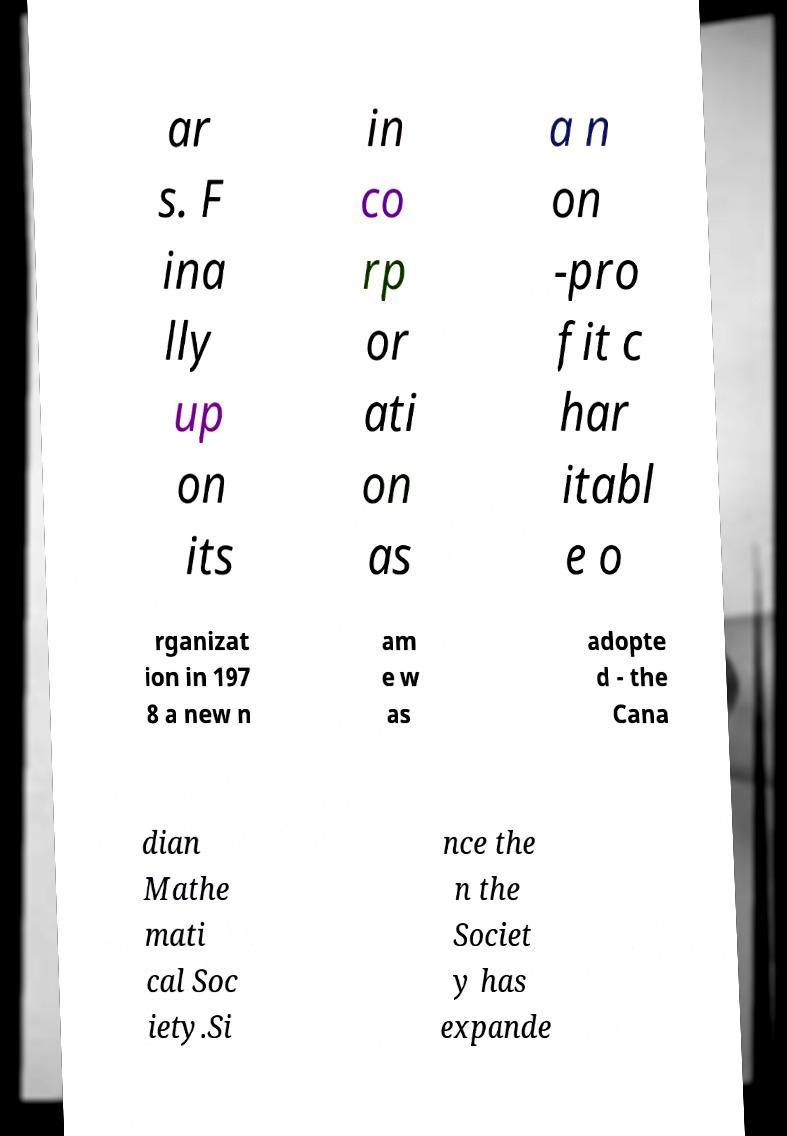Can you read and provide the text displayed in the image?This photo seems to have some interesting text. Can you extract and type it out for me? ar s. F ina lly up on its in co rp or ati on as a n on -pro fit c har itabl e o rganizat ion in 197 8 a new n am e w as adopte d - the Cana dian Mathe mati cal Soc iety.Si nce the n the Societ y has expande 